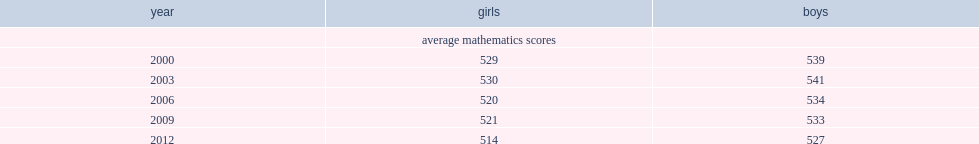Who scored higher in mathematics in 2012,boys or girls? Boys. 